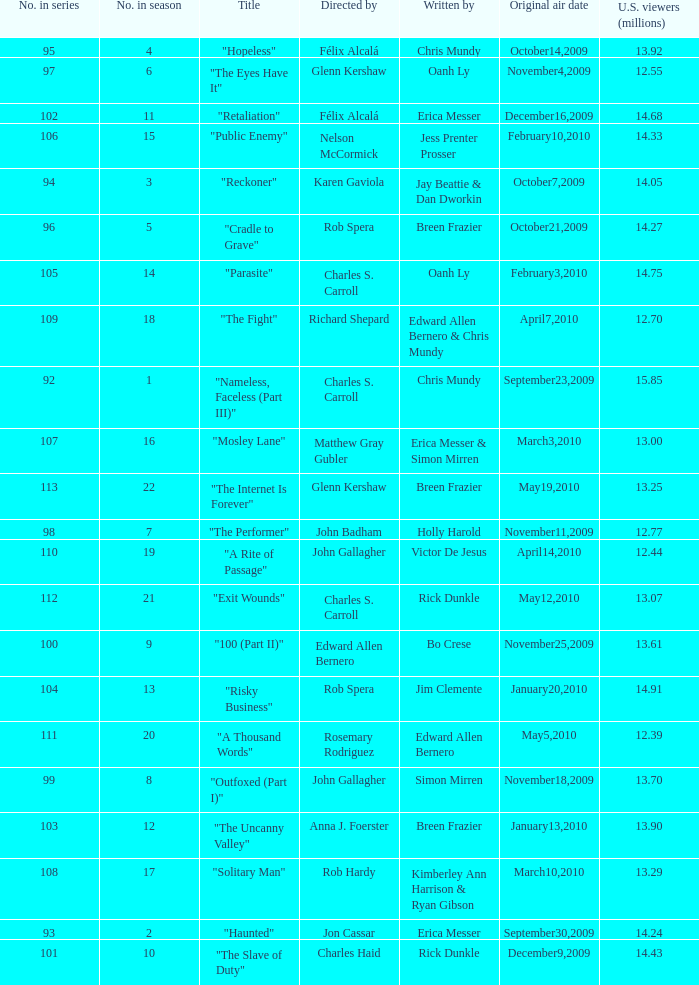What number(s) in the series was written by bo crese? 100.0. 